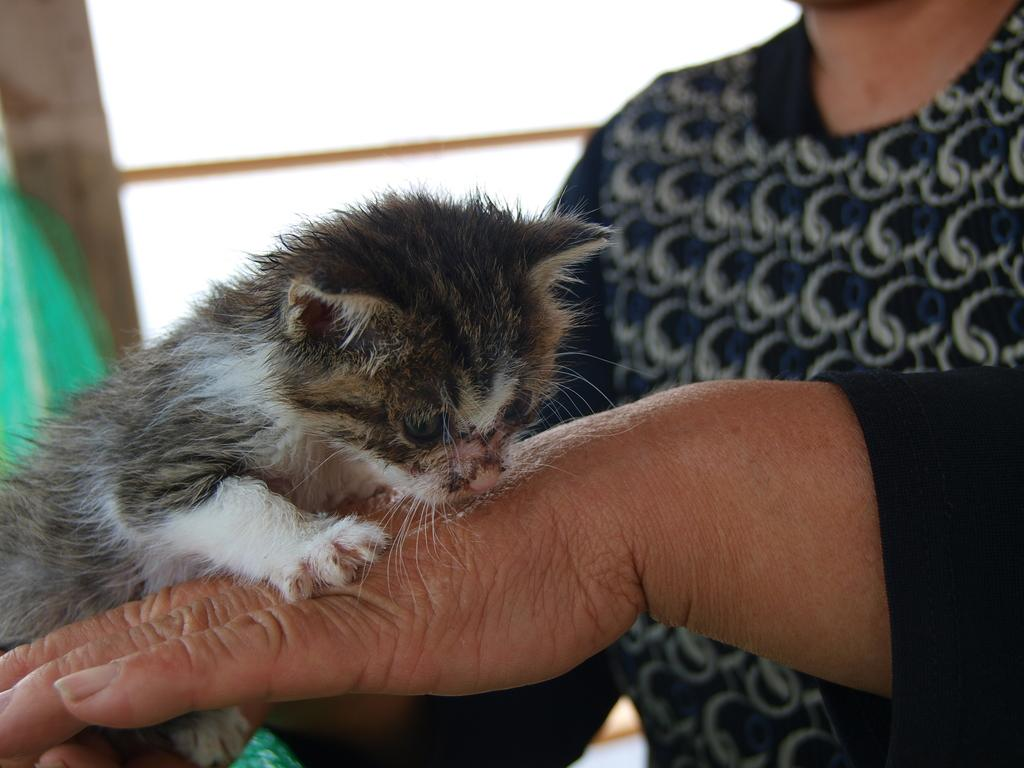What type of animal is in the image? There is a small cat in the image. Where is the cat located in the image? The cat is on a person's hand. What is the person wearing in the image? The person is wearing a blue t-shirt. What can be seen in the background of the image? There is a window visible in the background of the image. What type of account does the cat have on social media? There is no information about the cat having a social media account in the image. 